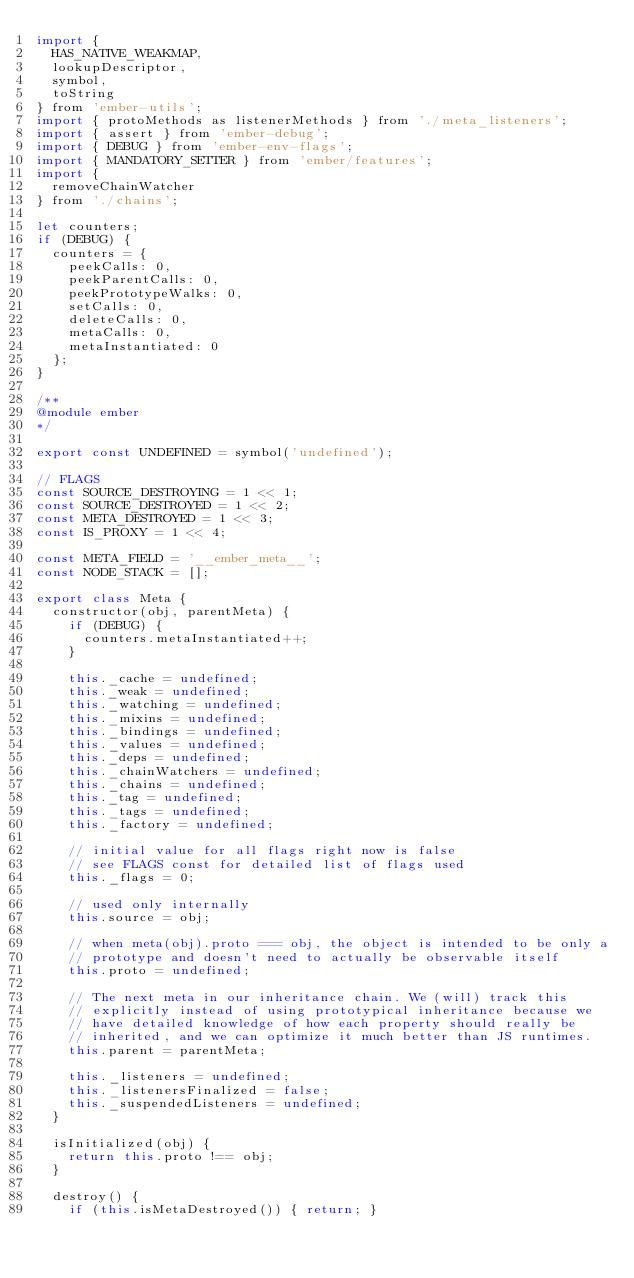<code> <loc_0><loc_0><loc_500><loc_500><_JavaScript_>import {
  HAS_NATIVE_WEAKMAP,
  lookupDescriptor,
  symbol,
  toString
} from 'ember-utils';
import { protoMethods as listenerMethods } from './meta_listeners';
import { assert } from 'ember-debug';
import { DEBUG } from 'ember-env-flags';
import { MANDATORY_SETTER } from 'ember/features';
import {
  removeChainWatcher
} from './chains';

let counters;
if (DEBUG) {
  counters = {
    peekCalls: 0,
    peekParentCalls: 0,
    peekPrototypeWalks: 0,
    setCalls: 0,
    deleteCalls: 0,
    metaCalls: 0,
    metaInstantiated: 0
  };
}

/**
@module ember
*/

export const UNDEFINED = symbol('undefined');

// FLAGS
const SOURCE_DESTROYING = 1 << 1;
const SOURCE_DESTROYED = 1 << 2;
const META_DESTROYED = 1 << 3;
const IS_PROXY = 1 << 4;

const META_FIELD = '__ember_meta__';
const NODE_STACK = [];

export class Meta {
  constructor(obj, parentMeta) {
    if (DEBUG) {
      counters.metaInstantiated++;
    }

    this._cache = undefined;
    this._weak = undefined;
    this._watching = undefined;
    this._mixins = undefined;
    this._bindings = undefined;
    this._values = undefined;
    this._deps = undefined;
    this._chainWatchers = undefined;
    this._chains = undefined;
    this._tag = undefined;
    this._tags = undefined;
    this._factory = undefined;

    // initial value for all flags right now is false
    // see FLAGS const for detailed list of flags used
    this._flags = 0;

    // used only internally
    this.source = obj;

    // when meta(obj).proto === obj, the object is intended to be only a
    // prototype and doesn't need to actually be observable itself
    this.proto = undefined;

    // The next meta in our inheritance chain. We (will) track this
    // explicitly instead of using prototypical inheritance because we
    // have detailed knowledge of how each property should really be
    // inherited, and we can optimize it much better than JS runtimes.
    this.parent = parentMeta;

    this._listeners = undefined;
    this._listenersFinalized = false;
    this._suspendedListeners = undefined;
  }

  isInitialized(obj) {
    return this.proto !== obj;
  }

  destroy() {
    if (this.isMetaDestroyed()) { return; }
</code> 